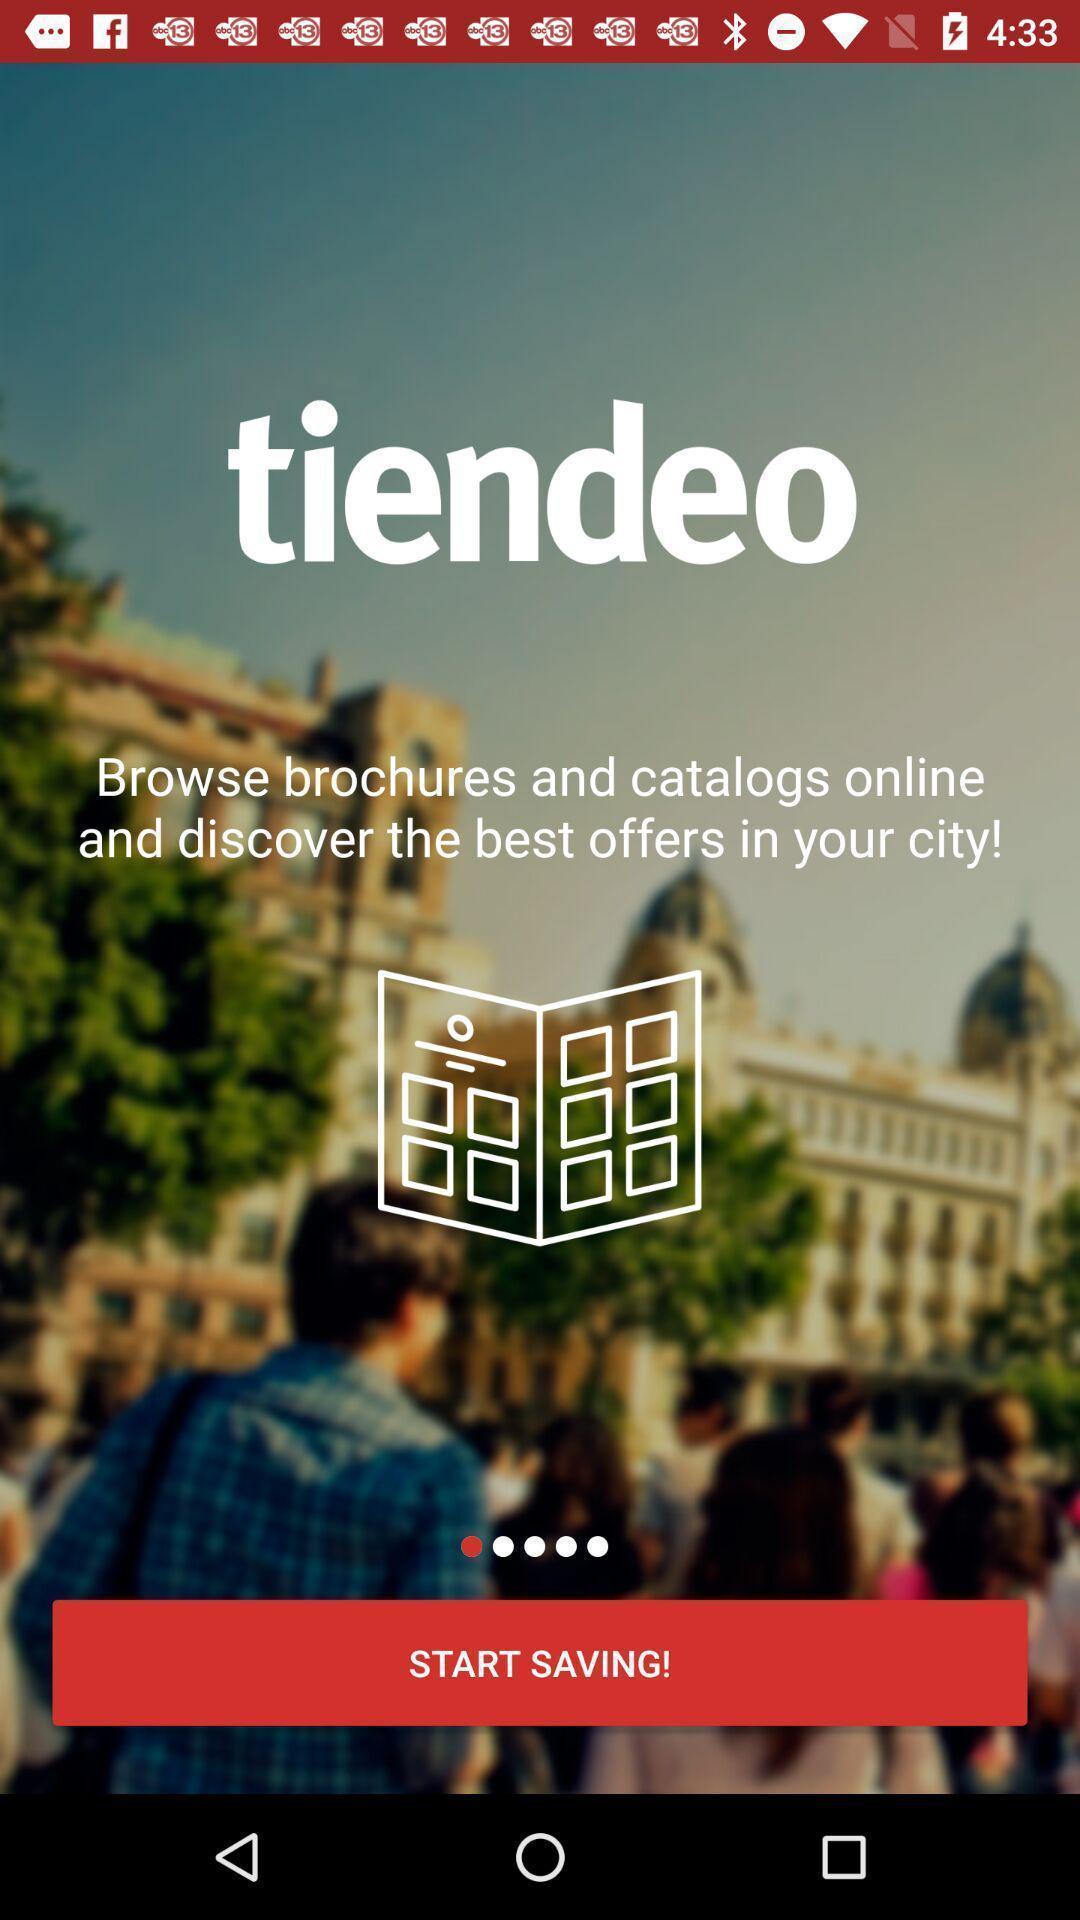Describe the visual elements of this screenshot. Welcome page of a financial app. 